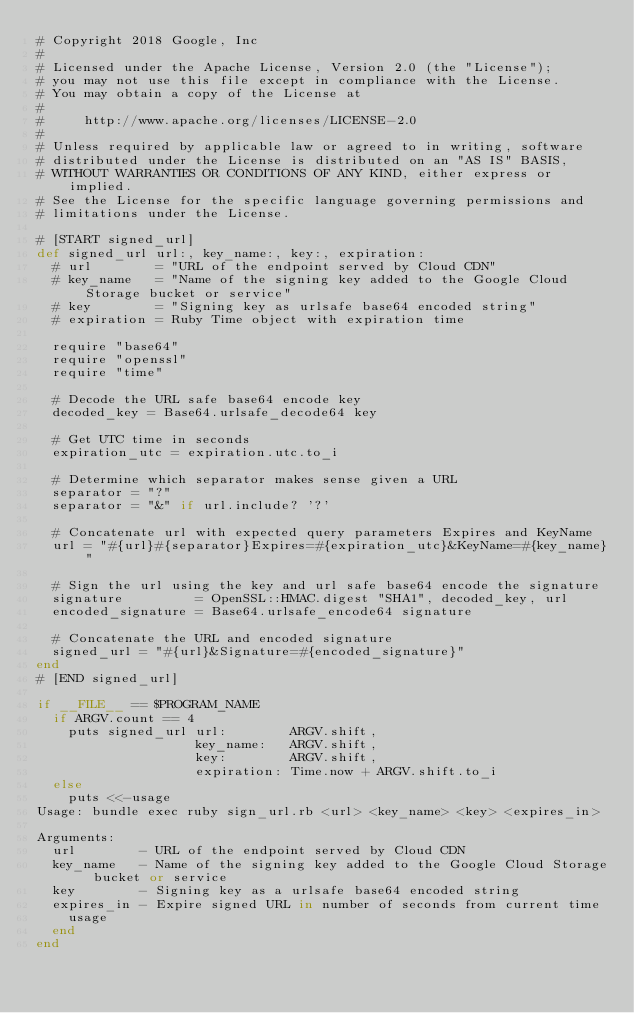Convert code to text. <code><loc_0><loc_0><loc_500><loc_500><_Ruby_># Copyright 2018 Google, Inc
#
# Licensed under the Apache License, Version 2.0 (the "License");
# you may not use this file except in compliance with the License.
# You may obtain a copy of the License at
#
#     http://www.apache.org/licenses/LICENSE-2.0
#
# Unless required by applicable law or agreed to in writing, software
# distributed under the License is distributed on an "AS IS" BASIS,
# WITHOUT WARRANTIES OR CONDITIONS OF ANY KIND, either express or implied.
# See the License for the specific language governing permissions and
# limitations under the License.

# [START signed_url]
def signed_url url:, key_name:, key:, expiration:
  # url        = "URL of the endpoint served by Cloud CDN"
  # key_name   = "Name of the signing key added to the Google Cloud Storage bucket or service"
  # key        = "Signing key as urlsafe base64 encoded string"
  # expiration = Ruby Time object with expiration time

  require "base64"
  require "openssl"
  require "time"

  # Decode the URL safe base64 encode key
  decoded_key = Base64.urlsafe_decode64 key

  # Get UTC time in seconds
  expiration_utc = expiration.utc.to_i

  # Determine which separator makes sense given a URL
  separator = "?"
  separator = "&" if url.include? '?'

  # Concatenate url with expected query parameters Expires and KeyName
  url = "#{url}#{separator}Expires=#{expiration_utc}&KeyName=#{key_name}"

  # Sign the url using the key and url safe base64 encode the signature
  signature         = OpenSSL::HMAC.digest "SHA1", decoded_key, url
  encoded_signature = Base64.urlsafe_encode64 signature

  # Concatenate the URL and encoded signature
  signed_url = "#{url}&Signature=#{encoded_signature}"
end
# [END signed_url]

if __FILE__ == $PROGRAM_NAME
  if ARGV.count == 4
    puts signed_url url:        ARGV.shift,
                    key_name:   ARGV.shift,
                    key:        ARGV.shift,
                    expiration: Time.now + ARGV.shift.to_i
  else
    puts <<-usage
Usage: bundle exec ruby sign_url.rb <url> <key_name> <key> <expires_in>

Arguments:
  url        - URL of the endpoint served by Cloud CDN
  key_name   - Name of the signing key added to the Google Cloud Storage bucket or service
  key        - Signing key as a urlsafe base64 encoded string
  expires_in - Expire signed URL in number of seconds from current time
    usage
  end
end
</code> 